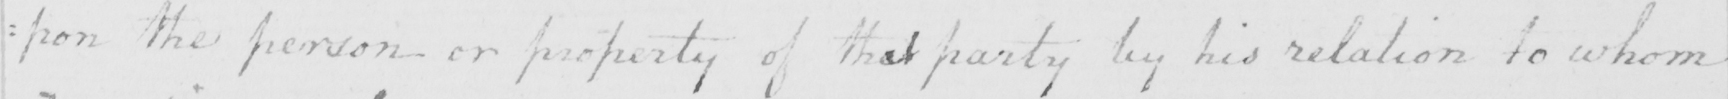What text is written in this handwritten line? =pon the person or property of that party by his relation to whom 